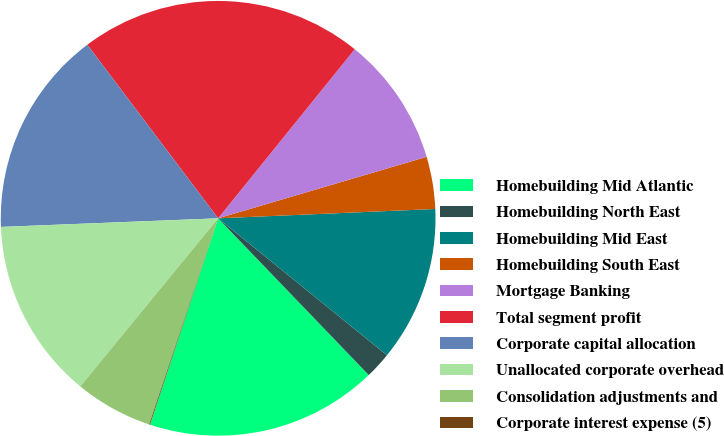<chart> <loc_0><loc_0><loc_500><loc_500><pie_chart><fcel>Homebuilding Mid Atlantic<fcel>Homebuilding North East<fcel>Homebuilding Mid East<fcel>Homebuilding South East<fcel>Mortgage Banking<fcel>Total segment profit<fcel>Corporate capital allocation<fcel>Unallocated corporate overhead<fcel>Consolidation adjustments and<fcel>Corporate interest expense (5)<nl><fcel>17.26%<fcel>1.97%<fcel>11.53%<fcel>3.88%<fcel>9.62%<fcel>21.09%<fcel>15.35%<fcel>13.44%<fcel>5.79%<fcel>0.06%<nl></chart> 